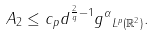<formula> <loc_0><loc_0><loc_500><loc_500>A _ { 2 } \leq c _ { p } d ^ { \frac { 2 } { q } - 1 } \| g ^ { \alpha } \| _ { L ^ { p } ( \mathbb { R } ^ { 2 } ) } .</formula> 